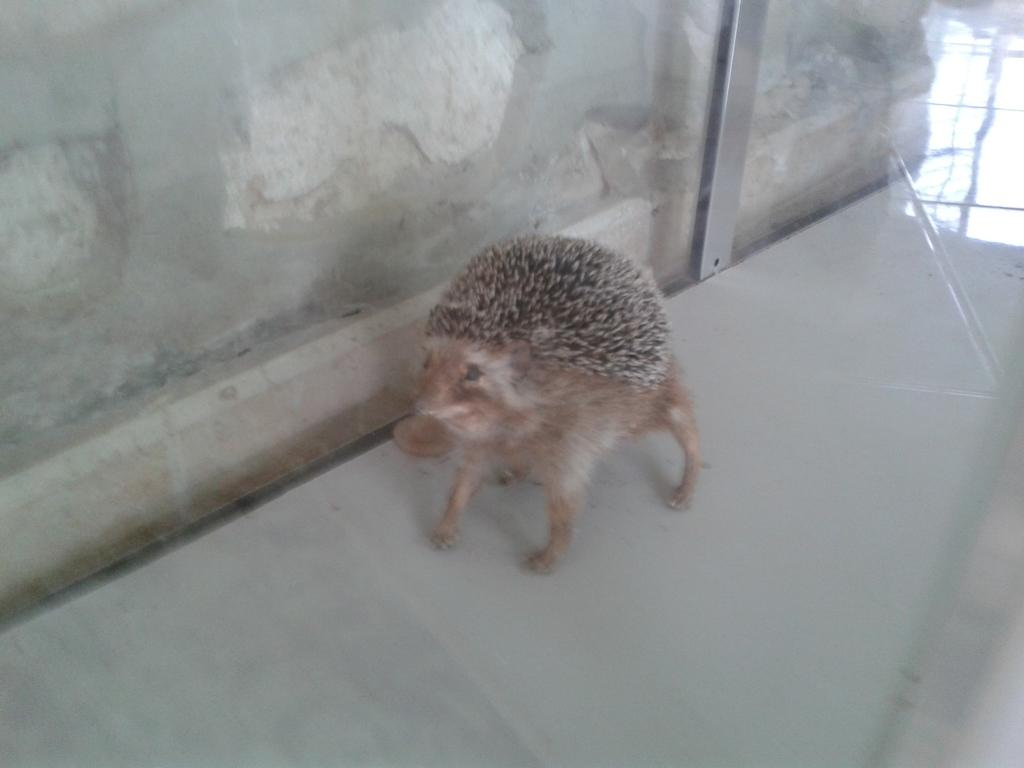What type of creature is in the image? There is an animal in the image. What color is the animal? The animal is brown in color. What is the animal standing on in the image? The animal is on a white surface. What can be seen in the background of the image? There is a wall visible in the image. Can you see the moon in the image? No, the moon is not present in the image. Is there a river visible in the image? No, there is no river visible in the image. 